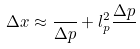Convert formula to latex. <formula><loc_0><loc_0><loc_500><loc_500>\Delta x \approx \frac { } { \Delta p } + l ^ { 2 } _ { p } \frac { \Delta p } { }</formula> 